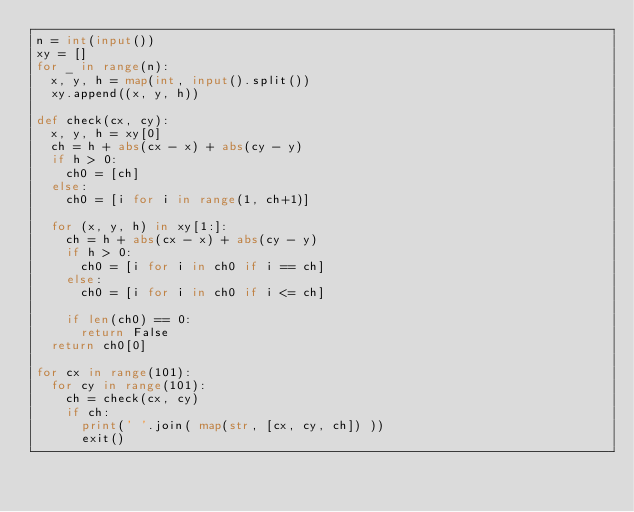<code> <loc_0><loc_0><loc_500><loc_500><_Python_>n = int(input())
xy = []
for _ in range(n):
  x, y, h = map(int, input().split())
  xy.append((x, y, h))

def check(cx, cy):
  x, y, h = xy[0]
  ch = h + abs(cx - x) + abs(cy - y)
  if h > 0:
    ch0 = [ch]
  else:
    ch0 = [i for i in range(1, ch+1)]
  
  for (x, y, h) in xy[1:]:
    ch = h + abs(cx - x) + abs(cy - y)
    if h > 0:
      ch0 = [i for i in ch0 if i == ch]
    else:
      ch0 = [i for i in ch0 if i <= ch]
    
    if len(ch0) == 0:
      return False
  return ch0[0]

for cx in range(101):
  for cy in range(101):
    ch = check(cx, cy)
    if ch:
      print(' '.join( map(str, [cx, cy, ch]) ))
      exit()

</code> 